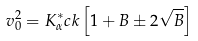Convert formula to latex. <formula><loc_0><loc_0><loc_500><loc_500>v _ { 0 } ^ { 2 } = K ^ { * } _ { \alpha } c k \left [ 1 + B \pm 2 \sqrt { B } \right ]</formula> 